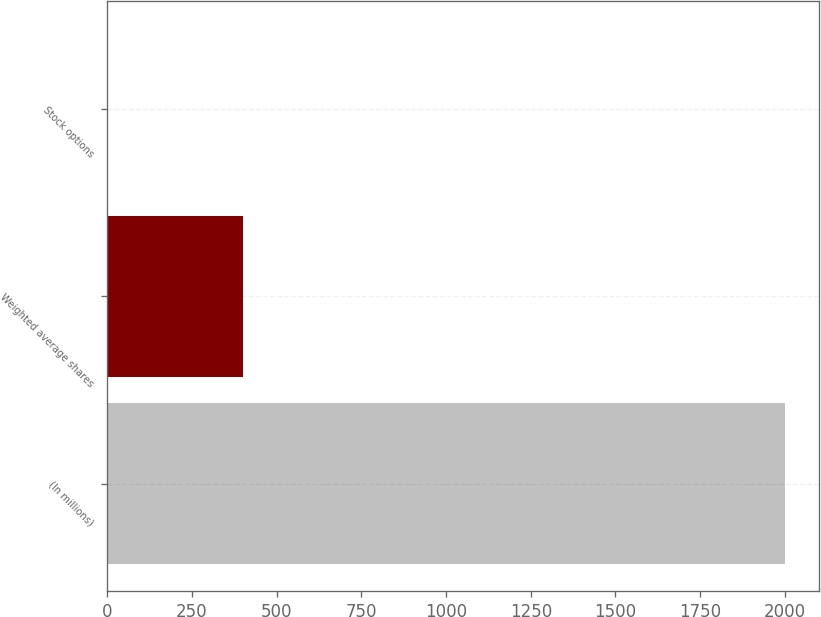Convert chart. <chart><loc_0><loc_0><loc_500><loc_500><bar_chart><fcel>(In millions)<fcel>Weighted average shares<fcel>Stock options<nl><fcel>2001<fcel>401.88<fcel>2.1<nl></chart> 